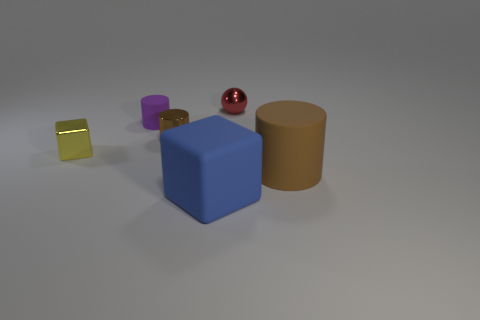Are the textures of the objects the same, and if not, which has the most unique texture? No, the objects display different textures. The golden yellow cube has a reflective glossy finish, the blue cube has a matte finish, and the red sphere and purple cylinder seem to have a satin finish. The golden yellow cube's reflective surface makes it the most unique among them. 